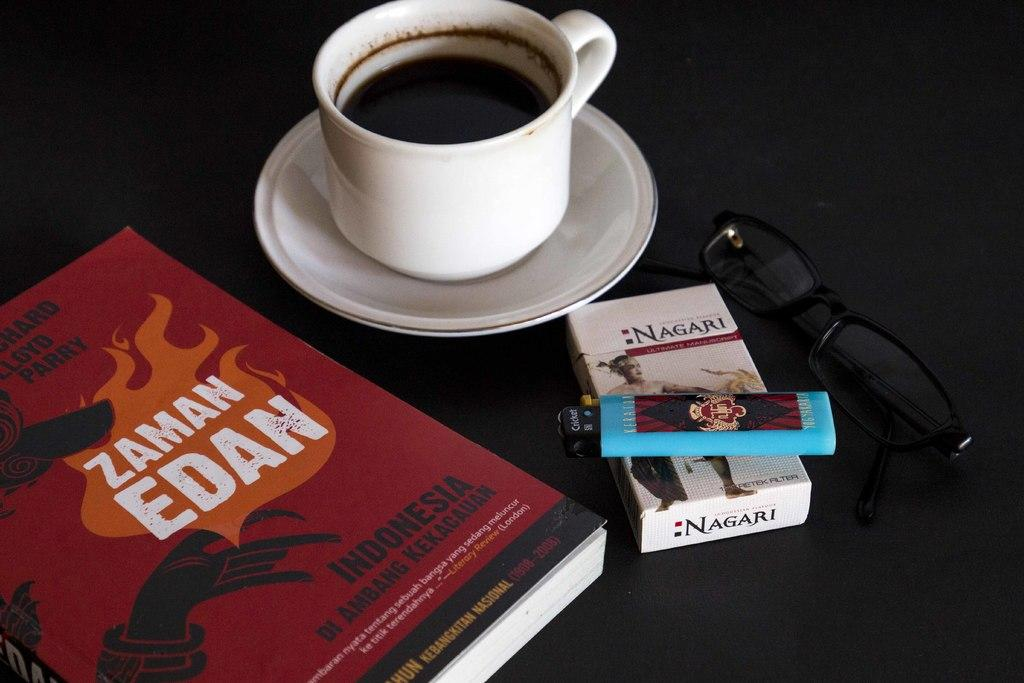<image>
Render a clear and concise summary of the photo. A red book named Zaman Edan sits next to a cup of coffee and a pair of glasses. 